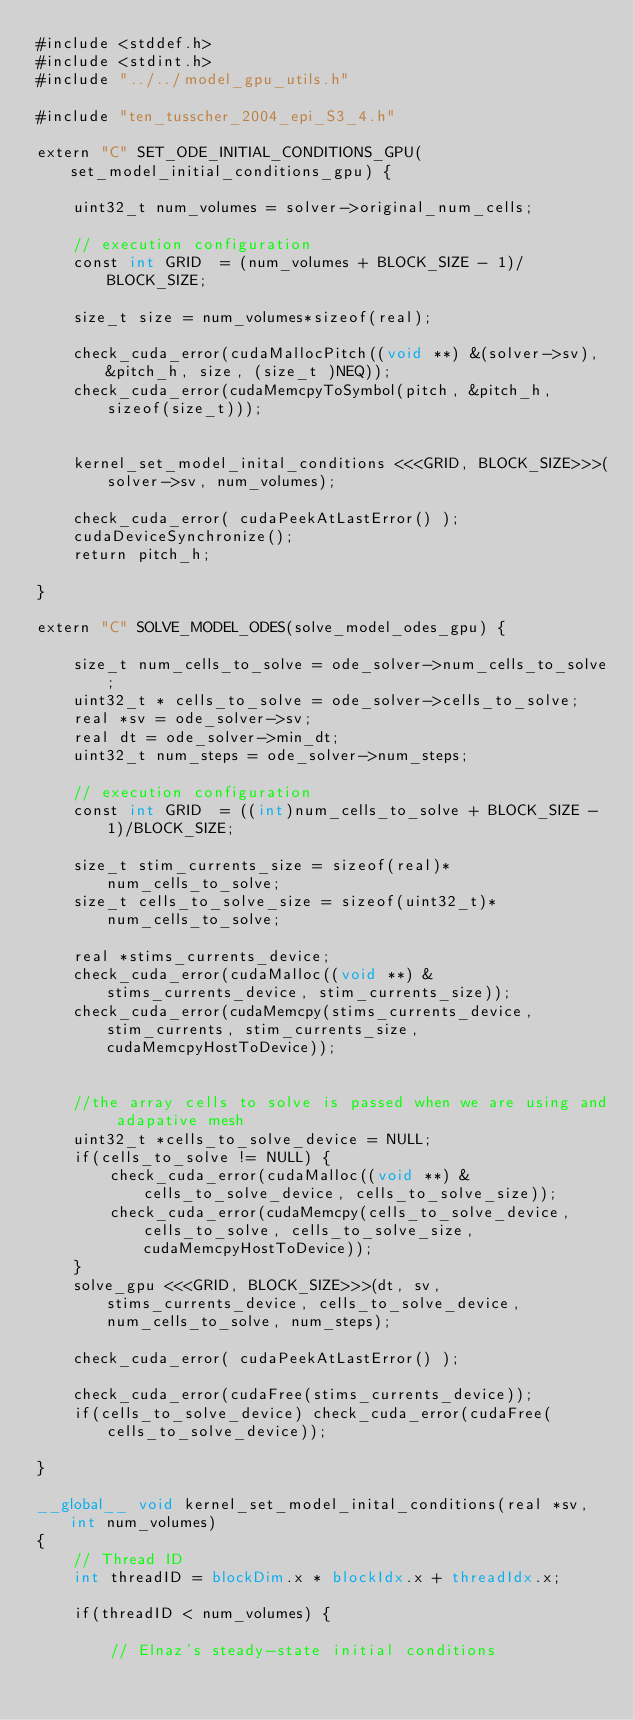<code> <loc_0><loc_0><loc_500><loc_500><_Cuda_>#include <stddef.h>
#include <stdint.h>
#include "../../model_gpu_utils.h"

#include "ten_tusscher_2004_epi_S3_4.h"

extern "C" SET_ODE_INITIAL_CONDITIONS_GPU(set_model_initial_conditions_gpu) {

    uint32_t num_volumes = solver->original_num_cells;

    // execution configuration
    const int GRID  = (num_volumes + BLOCK_SIZE - 1)/BLOCK_SIZE;

    size_t size = num_volumes*sizeof(real);

    check_cuda_error(cudaMallocPitch((void **) &(solver->sv), &pitch_h, size, (size_t )NEQ));
    check_cuda_error(cudaMemcpyToSymbol(pitch, &pitch_h, sizeof(size_t)));


    kernel_set_model_inital_conditions <<<GRID, BLOCK_SIZE>>>(solver->sv, num_volumes);

    check_cuda_error( cudaPeekAtLastError() );
    cudaDeviceSynchronize();
    return pitch_h;

}

extern "C" SOLVE_MODEL_ODES(solve_model_odes_gpu) {

    size_t num_cells_to_solve = ode_solver->num_cells_to_solve;
    uint32_t * cells_to_solve = ode_solver->cells_to_solve;
    real *sv = ode_solver->sv;
    real dt = ode_solver->min_dt;
    uint32_t num_steps = ode_solver->num_steps;

    // execution configuration
    const int GRID  = ((int)num_cells_to_solve + BLOCK_SIZE - 1)/BLOCK_SIZE;

    size_t stim_currents_size = sizeof(real)*num_cells_to_solve;
    size_t cells_to_solve_size = sizeof(uint32_t)*num_cells_to_solve;

    real *stims_currents_device;
    check_cuda_error(cudaMalloc((void **) &stims_currents_device, stim_currents_size));
    check_cuda_error(cudaMemcpy(stims_currents_device, stim_currents, stim_currents_size, cudaMemcpyHostToDevice));


    //the array cells to solve is passed when we are using and adapative mesh
    uint32_t *cells_to_solve_device = NULL;
    if(cells_to_solve != NULL) {
        check_cuda_error(cudaMalloc((void **) &cells_to_solve_device, cells_to_solve_size));
        check_cuda_error(cudaMemcpy(cells_to_solve_device, cells_to_solve, cells_to_solve_size, cudaMemcpyHostToDevice));
    }
    solve_gpu <<<GRID, BLOCK_SIZE>>>(dt, sv, stims_currents_device, cells_to_solve_device, num_cells_to_solve, num_steps);

    check_cuda_error( cudaPeekAtLastError() );

    check_cuda_error(cudaFree(stims_currents_device));
    if(cells_to_solve_device) check_cuda_error(cudaFree(cells_to_solve_device));

}

__global__ void kernel_set_model_inital_conditions(real *sv, int num_volumes)
{
    // Thread ID
    int threadID = blockDim.x * blockIdx.x + threadIdx.x;

    if(threadID < num_volumes) {

        // Elnaz's steady-state initial conditions</code> 